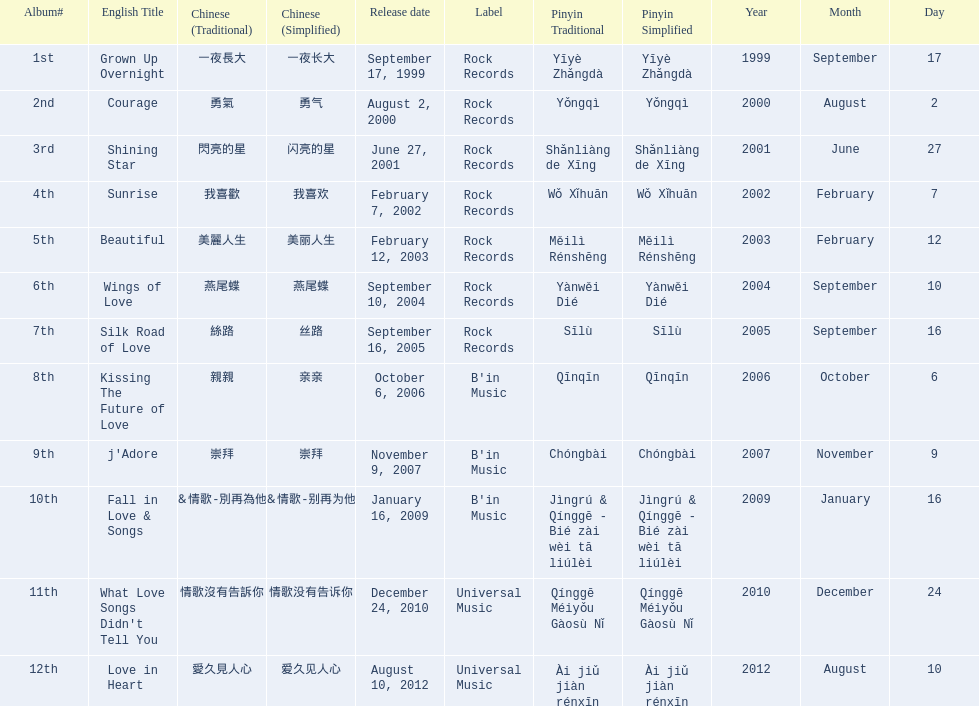What label was she working with before universal music? B'in Music. 